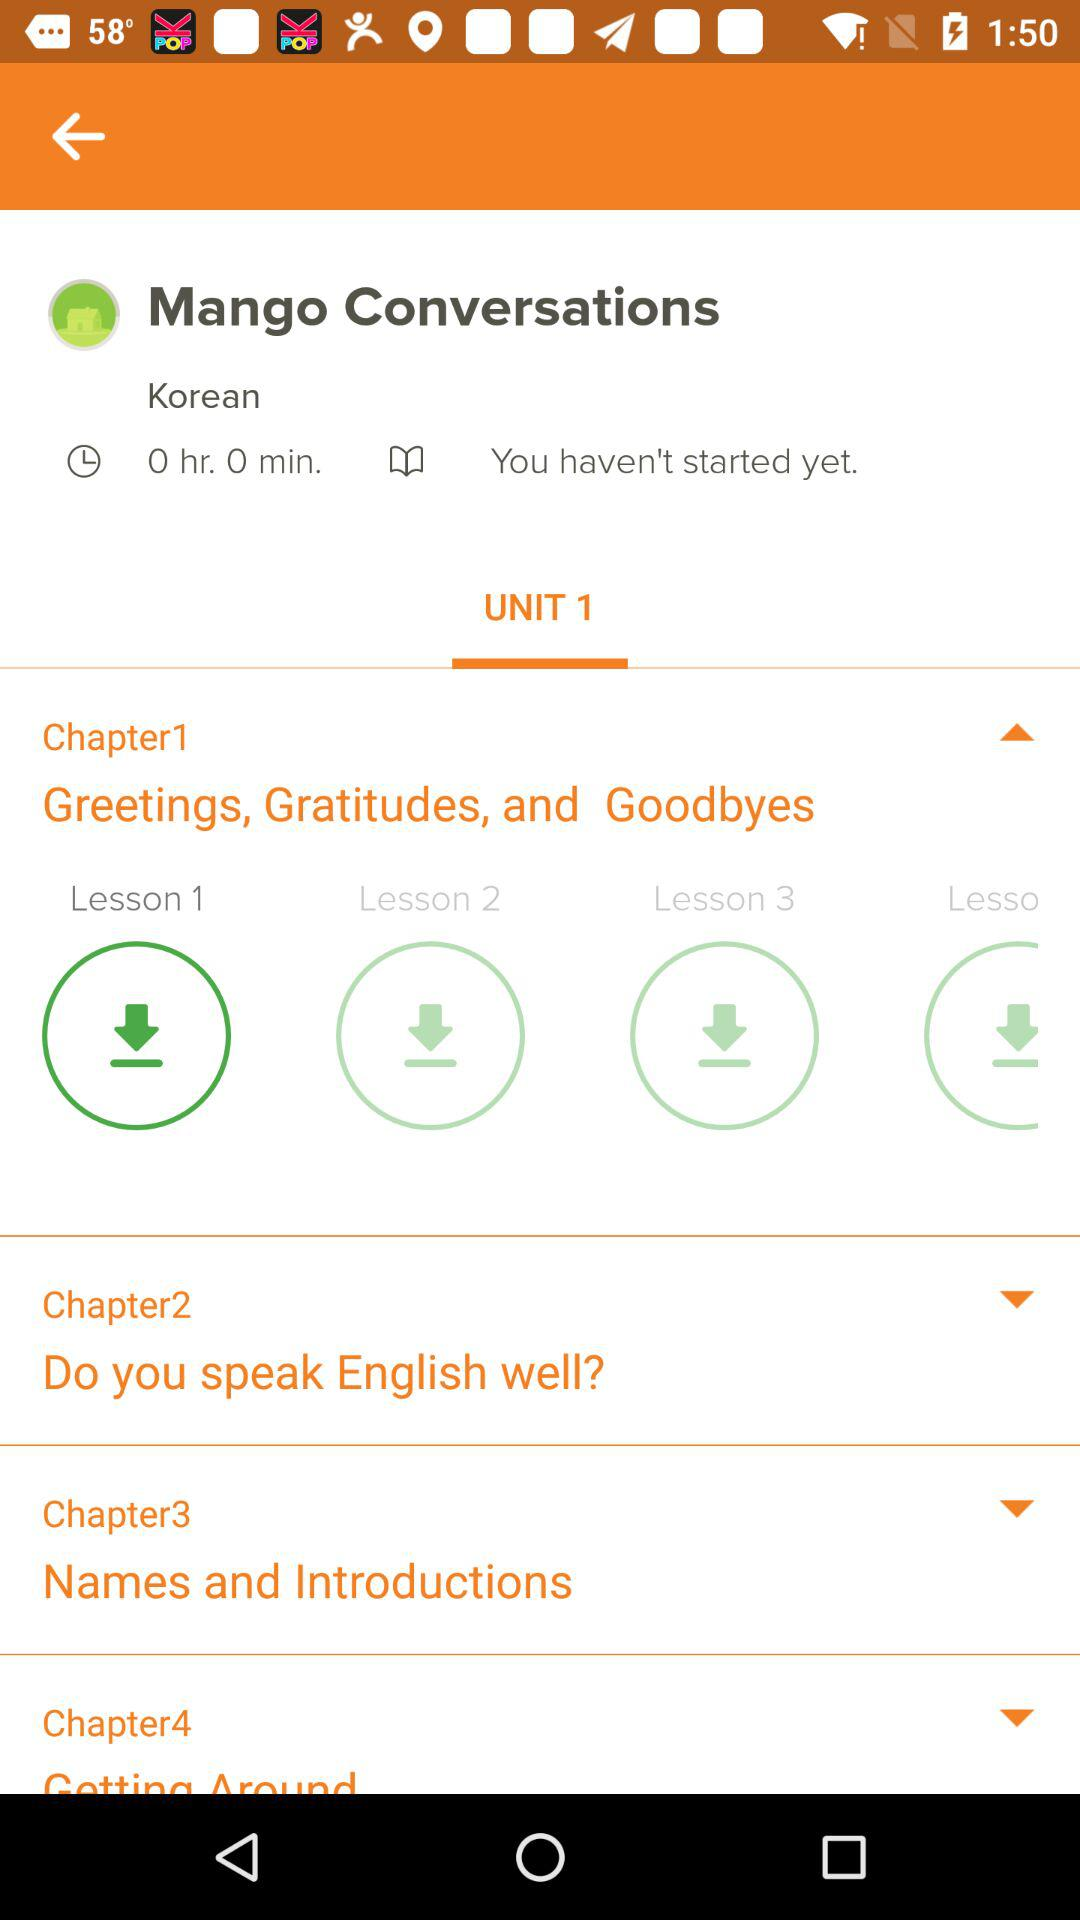How would 'Greetings, Gratitudes, and Goodbyes' be relevant to a beginner in language learning? For beginners, mastering 'Greetings, Gratitudes, and Goodbyes' is crucial as these phrases form the foundation for daily interaction and politeness in any language. By starting with these basics, learners can effectively begin and end conversations, making a positive impression while practicing essential vocabulary and pronunciation. 